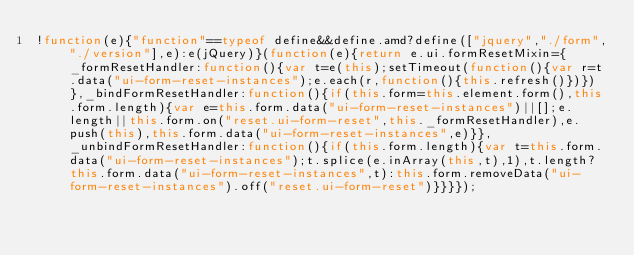<code> <loc_0><loc_0><loc_500><loc_500><_JavaScript_>!function(e){"function"==typeof define&&define.amd?define(["jquery","./form","./version"],e):e(jQuery)}(function(e){return e.ui.formResetMixin={_formResetHandler:function(){var t=e(this);setTimeout(function(){var r=t.data("ui-form-reset-instances");e.each(r,function(){this.refresh()})})},_bindFormResetHandler:function(){if(this.form=this.element.form(),this.form.length){var e=this.form.data("ui-form-reset-instances")||[];e.length||this.form.on("reset.ui-form-reset",this._formResetHandler),e.push(this),this.form.data("ui-form-reset-instances",e)}},_unbindFormResetHandler:function(){if(this.form.length){var t=this.form.data("ui-form-reset-instances");t.splice(e.inArray(this,t),1),t.length?this.form.data("ui-form-reset-instances",t):this.form.removeData("ui-form-reset-instances").off("reset.ui-form-reset")}}}});</code> 